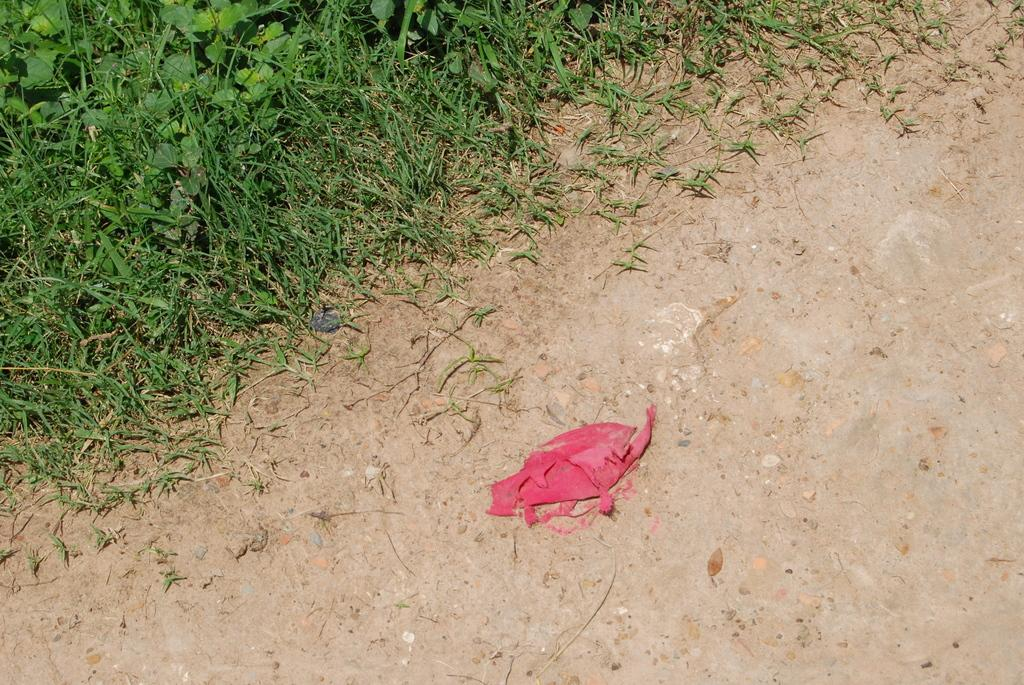What is the color of the cloth-like object on the ground in the foreground? The cloth-like object on the ground in the foreground is red. What type of vegetation can be seen at the top of the image? Grass is visible at the top of the image. How does the red cloth-like object in the image plan to attack the grass? The red cloth-like object in the image does not plan to attack the grass, as it is an inanimate object and cannot perform actions like attacking. 